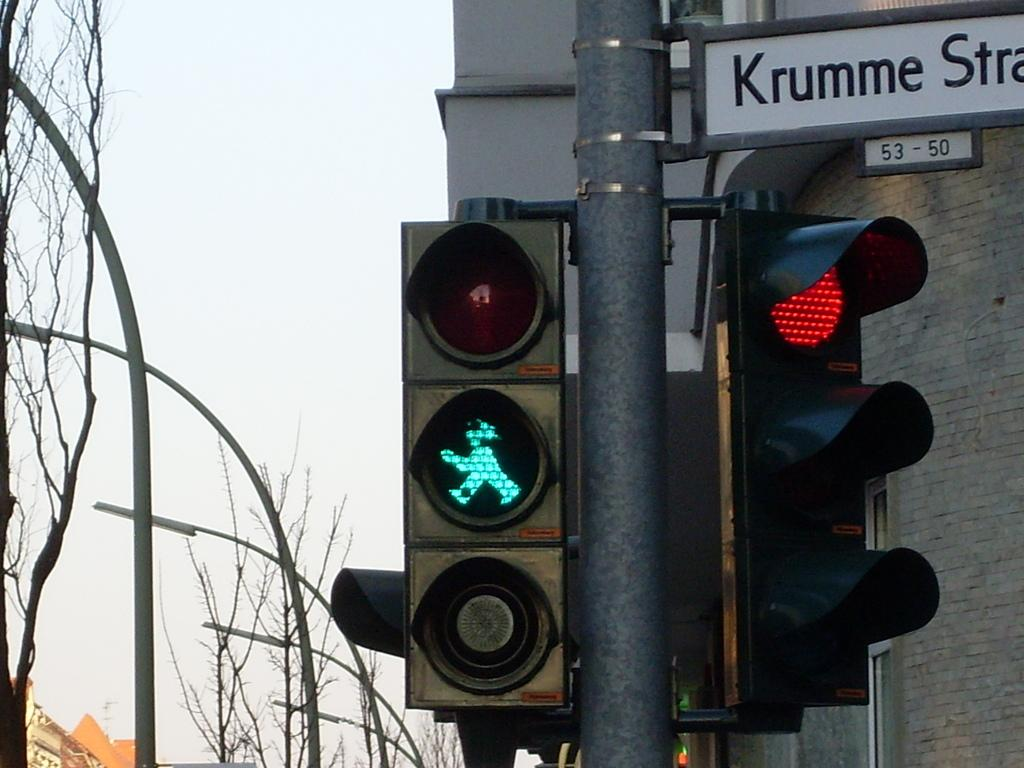<image>
Present a compact description of the photo's key features. A sign for Krumme Stra sits above a red stop light 